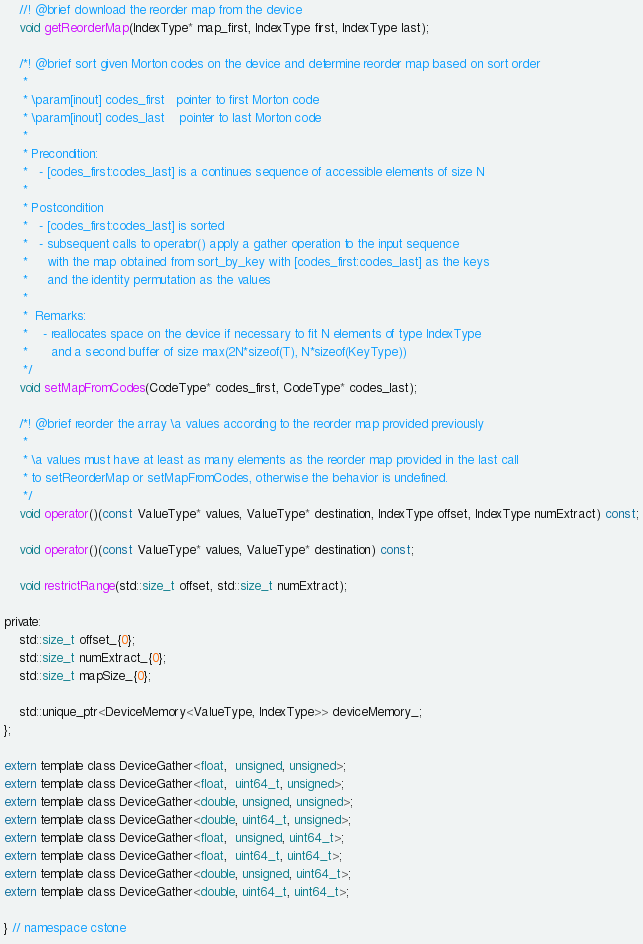Convert code to text. <code><loc_0><loc_0><loc_500><loc_500><_Cuda_>    //! @brief download the reorder map from the device
    void getReorderMap(IndexType* map_first, IndexType first, IndexType last);

    /*! @brief sort given Morton codes on the device and determine reorder map based on sort order
     *
     * \param[inout] codes_first   pointer to first Morton code
     * \param[inout] codes_last    pointer to last Morton code
     *
     * Precondition:
     *   - [codes_first:codes_last] is a continues sequence of accessible elements of size N
     *
     * Postcondition
     *   - [codes_first:codes_last] is sorted
     *   - subsequent calls to operator() apply a gather operation to the input sequence
     *     with the map obtained from sort_by_key with [codes_first:codes_last] as the keys
     *     and the identity permutation as the values
     *
     *  Remarks:
     *    - reallocates space on the device if necessary to fit N elements of type IndexType
     *      and a second buffer of size max(2N*sizeof(T), N*sizeof(KeyType))
     */
    void setMapFromCodes(CodeType* codes_first, CodeType* codes_last);

    /*! @brief reorder the array \a values according to the reorder map provided previously
     *
     * \a values must have at least as many elements as the reorder map provided in the last call
     * to setReorderMap or setMapFromCodes, otherwise the behavior is undefined.
     */
    void operator()(const ValueType* values, ValueType* destination, IndexType offset, IndexType numExtract) const;

    void operator()(const ValueType* values, ValueType* destination) const;

    void restrictRange(std::size_t offset, std::size_t numExtract);

private:
    std::size_t offset_{0};
    std::size_t numExtract_{0};
    std::size_t mapSize_{0};

    std::unique_ptr<DeviceMemory<ValueType, IndexType>> deviceMemory_;
};

extern template class DeviceGather<float,  unsigned, unsigned>;
extern template class DeviceGather<float,  uint64_t, unsigned>;
extern template class DeviceGather<double, unsigned, unsigned>;
extern template class DeviceGather<double, uint64_t, unsigned>;
extern template class DeviceGather<float,  unsigned, uint64_t>;
extern template class DeviceGather<float,  uint64_t, uint64_t>;
extern template class DeviceGather<double, unsigned, uint64_t>;
extern template class DeviceGather<double, uint64_t, uint64_t>;

} // namespace cstone
</code> 